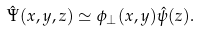Convert formula to latex. <formula><loc_0><loc_0><loc_500><loc_500>\hat { \Psi } ( x , y , z ) \simeq \phi _ { \perp } ( x , y ) \hat { \psi } ( z ) .</formula> 